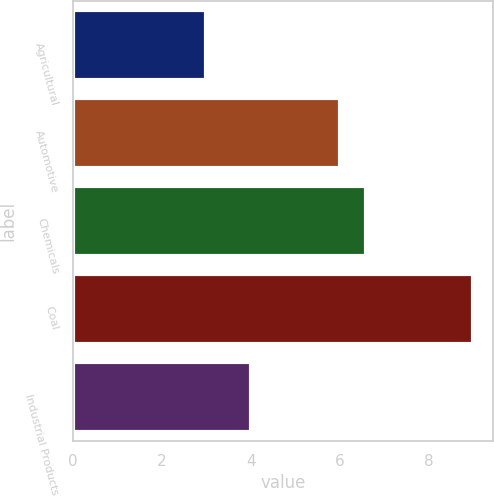Convert chart to OTSL. <chart><loc_0><loc_0><loc_500><loc_500><bar_chart><fcel>Agricultural<fcel>Automotive<fcel>Chemicals<fcel>Coal<fcel>Industrial Products<nl><fcel>3<fcel>6<fcel>6.6<fcel>9<fcel>4<nl></chart> 